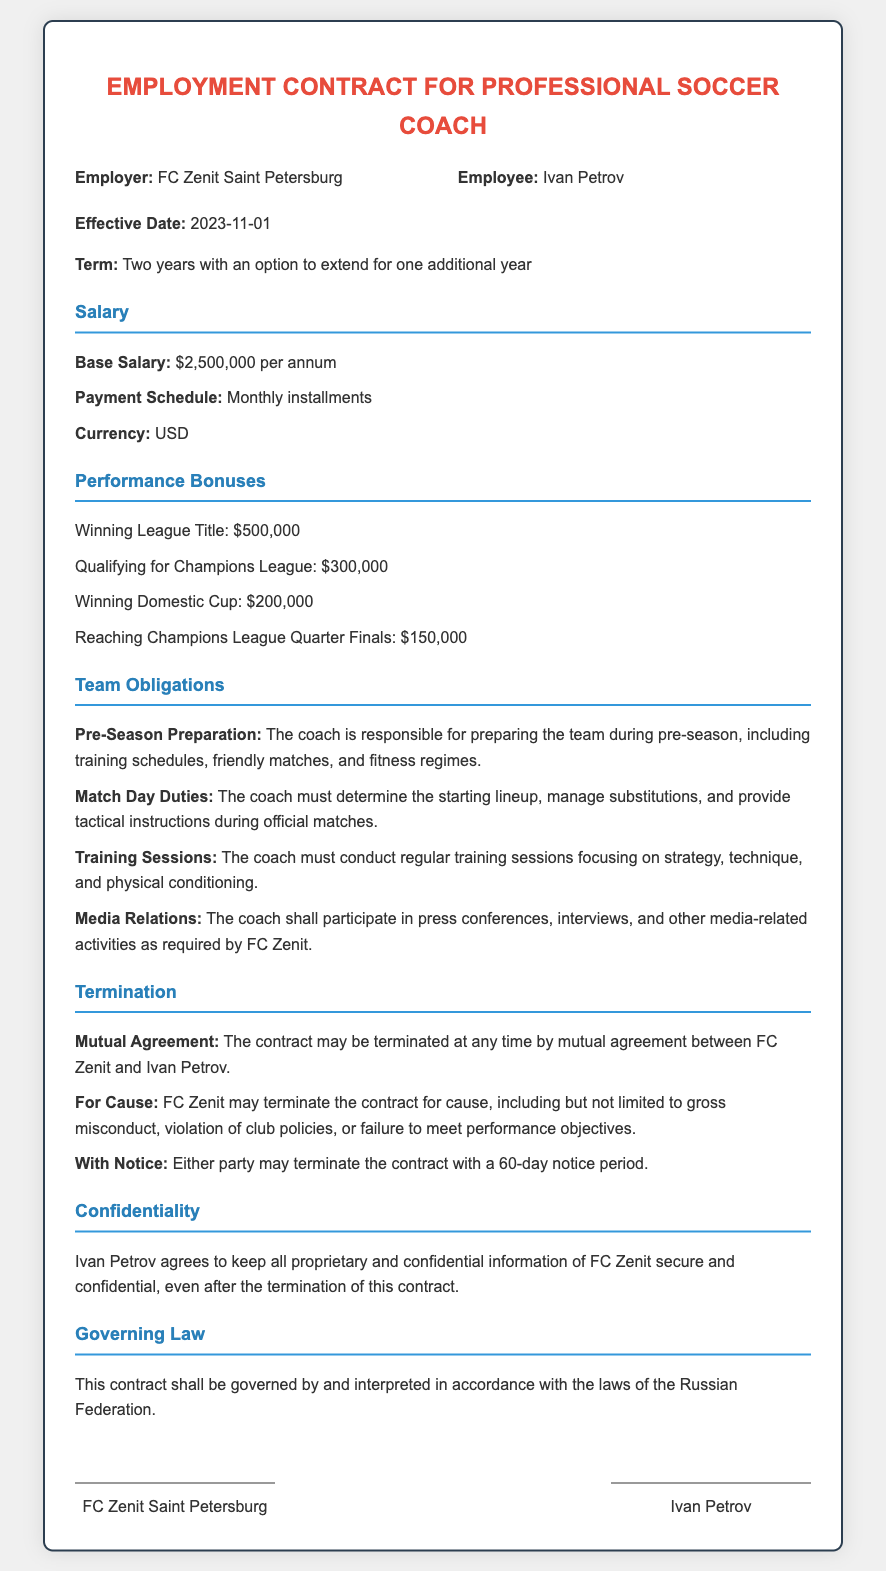what is the base salary? The base salary is explicitly stated in the document under the salary section, which is $2,500,000 per annum.
Answer: $2,500,000 per annum who is the employee? The employee's name is mentioned in the parties section of the document, which is Ivan Petrov.
Answer: Ivan Petrov what is the termination notice period? The document specifies the required notice period for termination as 60 days.
Answer: 60 days which team is in the contract? The employer's name, which refers to the team involved in the contract, is mentioned in the parties section as FC Zenit Saint Petersburg.
Answer: FC Zenit Saint Petersburg what bonus is given for winning the league title? The amount awarded for winning the league title is listed under performance bonuses in the document, which is $500,000.
Answer: $500,000 how long is the contract term? The contract term is described in the introduction part, stating that it lasts for two years with an option to extend for one additional year.
Answer: Two years with an option to extend for one additional year what is the governing law of the contract? The governing law is mentioned at the end of the contract, which specifies that it shall be governed by the laws of the Russian Federation.
Answer: laws of the Russian Federation what is the duty during match days? The document specifies that the coach must determine the starting lineup, manage substitutions, and provide tactical instructions during official matches.
Answer: determine the starting lineup, manage substitutions, and provide tactical instructions what happens if there is mutual agreement? It states under termination that the contract may be terminated at any time by mutual agreement between FC Zenit and Ivan Petrov.
Answer: terminated at any time by mutual agreement 